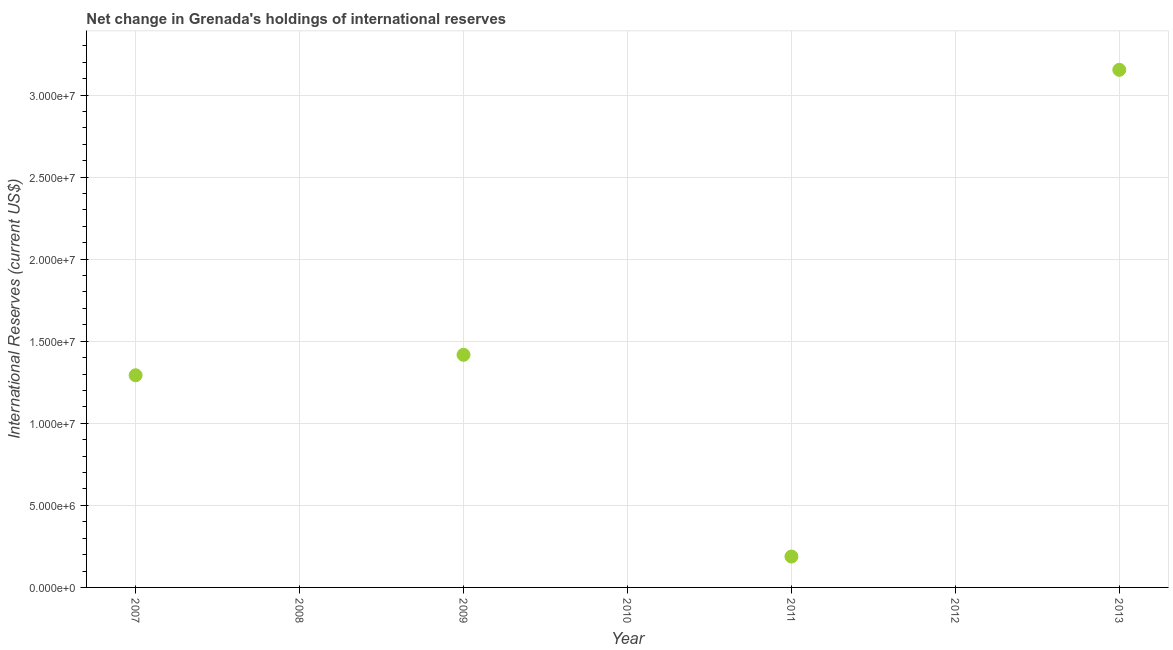What is the reserves and related items in 2012?
Ensure brevity in your answer.  0. Across all years, what is the maximum reserves and related items?
Make the answer very short. 3.15e+07. In which year was the reserves and related items maximum?
Your answer should be compact. 2013. What is the sum of the reserves and related items?
Make the answer very short. 6.05e+07. What is the difference between the reserves and related items in 2009 and 2013?
Your response must be concise. -1.74e+07. What is the average reserves and related items per year?
Provide a short and direct response. 8.65e+06. What is the median reserves and related items?
Give a very brief answer. 1.88e+06. In how many years, is the reserves and related items greater than 12000000 US$?
Your response must be concise. 3. Is the reserves and related items in 2007 less than that in 2013?
Provide a succinct answer. Yes. What is the difference between the highest and the second highest reserves and related items?
Ensure brevity in your answer.  1.74e+07. Is the sum of the reserves and related items in 2007 and 2013 greater than the maximum reserves and related items across all years?
Offer a terse response. Yes. What is the difference between the highest and the lowest reserves and related items?
Your answer should be very brief. 3.15e+07. Are the values on the major ticks of Y-axis written in scientific E-notation?
Provide a short and direct response. Yes. Does the graph contain grids?
Give a very brief answer. Yes. What is the title of the graph?
Give a very brief answer. Net change in Grenada's holdings of international reserves. What is the label or title of the Y-axis?
Provide a succinct answer. International Reserves (current US$). What is the International Reserves (current US$) in 2007?
Offer a terse response. 1.29e+07. What is the International Reserves (current US$) in 2008?
Your response must be concise. 0. What is the International Reserves (current US$) in 2009?
Your response must be concise. 1.42e+07. What is the International Reserves (current US$) in 2011?
Provide a short and direct response. 1.88e+06. What is the International Reserves (current US$) in 2013?
Your answer should be very brief. 3.15e+07. What is the difference between the International Reserves (current US$) in 2007 and 2009?
Give a very brief answer. -1.25e+06. What is the difference between the International Reserves (current US$) in 2007 and 2011?
Provide a short and direct response. 1.10e+07. What is the difference between the International Reserves (current US$) in 2007 and 2013?
Ensure brevity in your answer.  -1.86e+07. What is the difference between the International Reserves (current US$) in 2009 and 2011?
Your answer should be compact. 1.23e+07. What is the difference between the International Reserves (current US$) in 2009 and 2013?
Your response must be concise. -1.74e+07. What is the difference between the International Reserves (current US$) in 2011 and 2013?
Your response must be concise. -2.97e+07. What is the ratio of the International Reserves (current US$) in 2007 to that in 2009?
Ensure brevity in your answer.  0.91. What is the ratio of the International Reserves (current US$) in 2007 to that in 2011?
Make the answer very short. 6.87. What is the ratio of the International Reserves (current US$) in 2007 to that in 2013?
Provide a succinct answer. 0.41. What is the ratio of the International Reserves (current US$) in 2009 to that in 2011?
Ensure brevity in your answer.  7.53. What is the ratio of the International Reserves (current US$) in 2009 to that in 2013?
Keep it short and to the point. 0.45. 